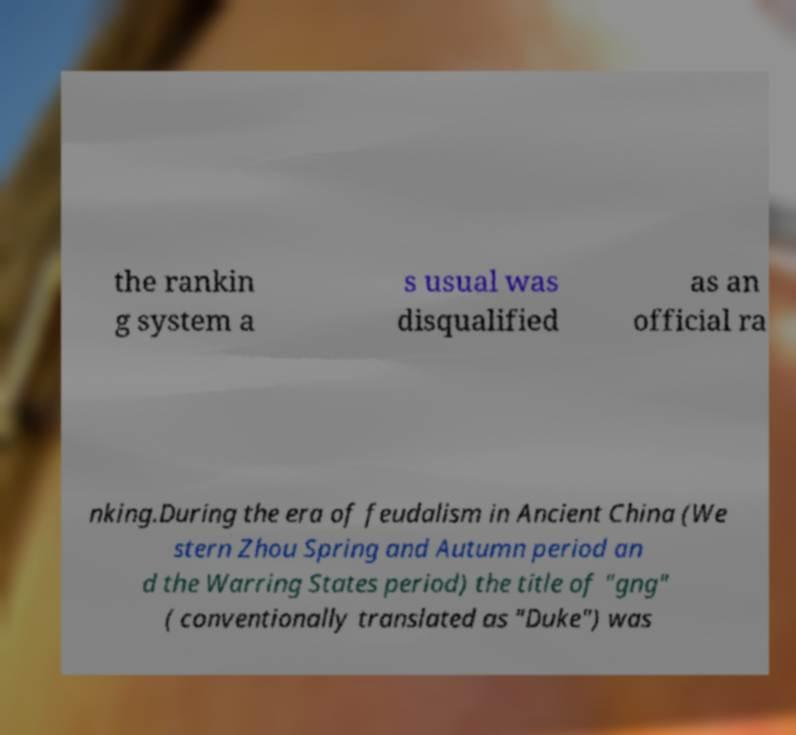Could you extract and type out the text from this image? the rankin g system a s usual was disqualified as an official ra nking.During the era of feudalism in Ancient China (We stern Zhou Spring and Autumn period an d the Warring States period) the title of "gng" ( conventionally translated as "Duke") was 